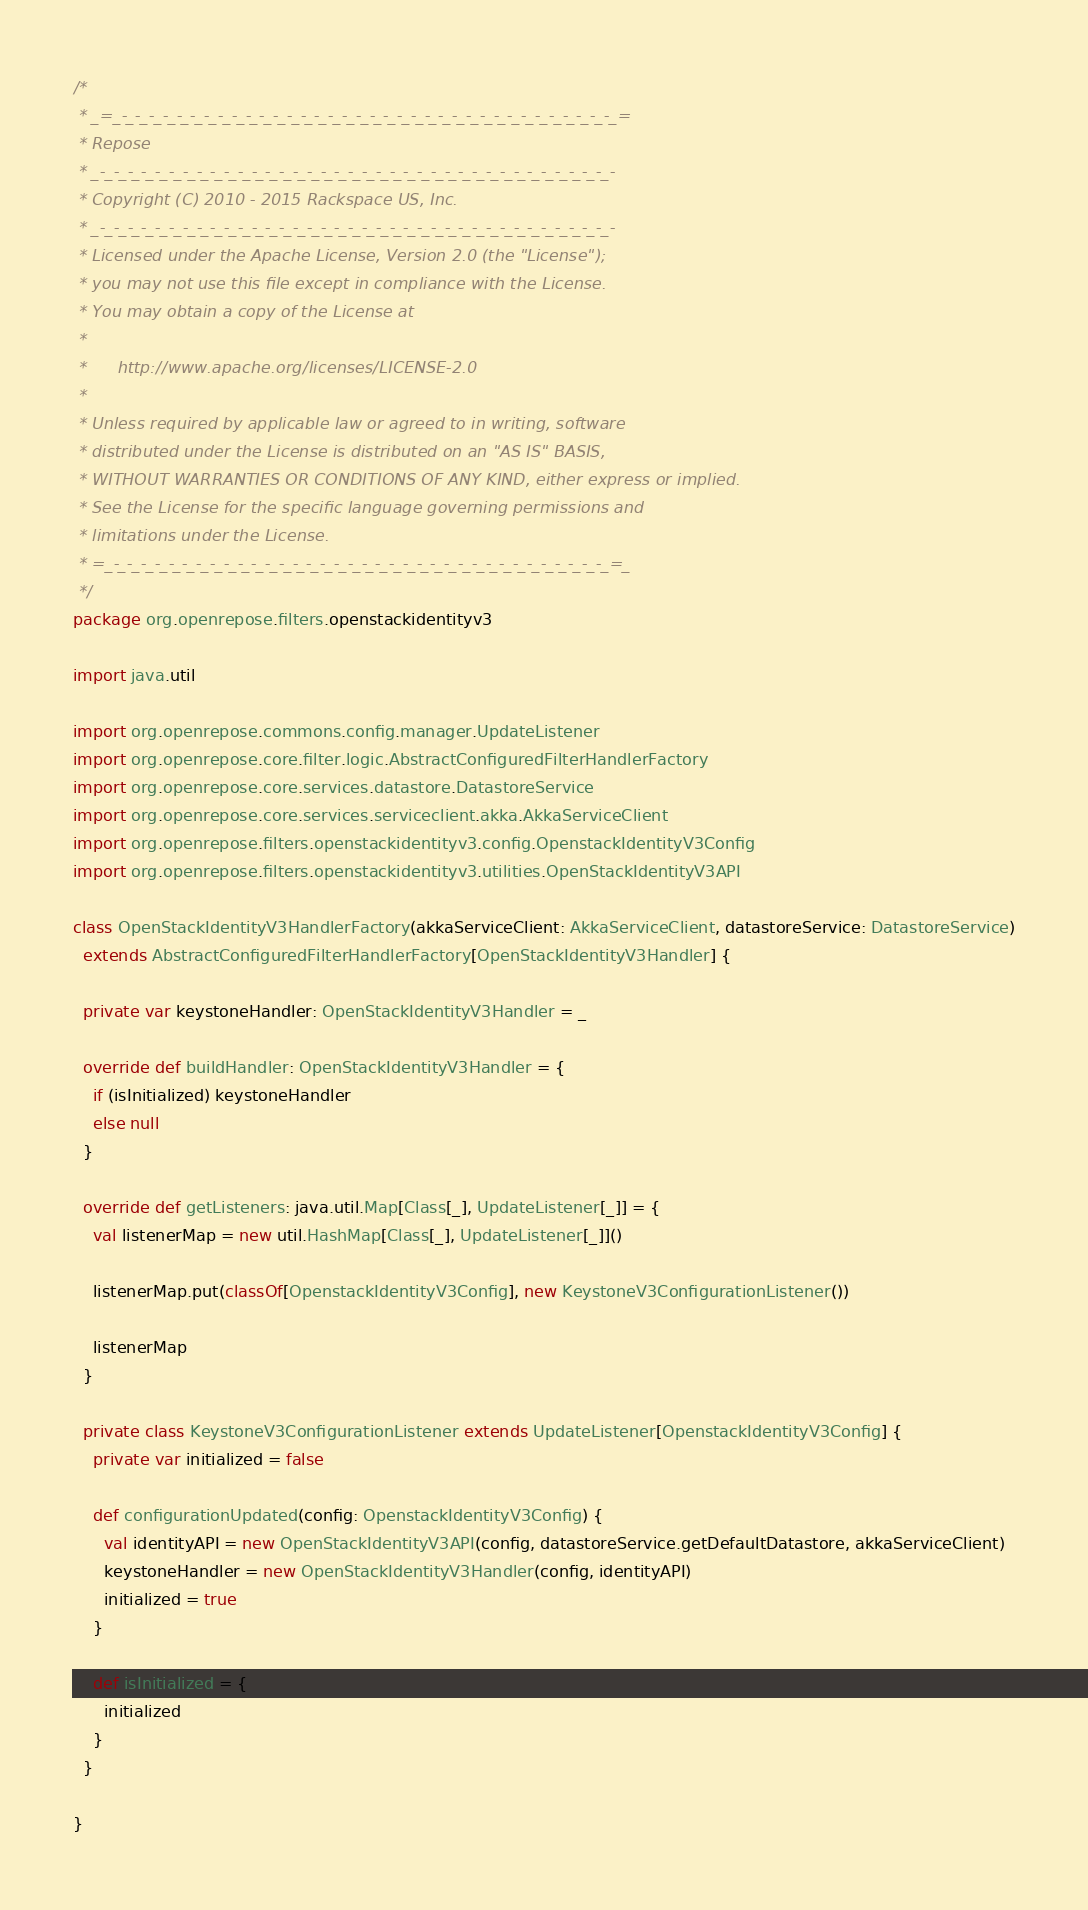Convert code to text. <code><loc_0><loc_0><loc_500><loc_500><_Scala_>/*
 * _=_-_-_-_-_-_-_-_-_-_-_-_-_-_-_-_-_-_-_-_-_-_-_-_-_-_-_-_-_-_-_-_-_-_-_-_-_=
 * Repose
 * _-_-_-_-_-_-_-_-_-_-_-_-_-_-_-_-_-_-_-_-_-_-_-_-_-_-_-_-_-_-_-_-_-_-_-_-_-_-
 * Copyright (C) 2010 - 2015 Rackspace US, Inc.
 * _-_-_-_-_-_-_-_-_-_-_-_-_-_-_-_-_-_-_-_-_-_-_-_-_-_-_-_-_-_-_-_-_-_-_-_-_-_-
 * Licensed under the Apache License, Version 2.0 (the "License");
 * you may not use this file except in compliance with the License.
 * You may obtain a copy of the License at
 * 
 *      http://www.apache.org/licenses/LICENSE-2.0
 * 
 * Unless required by applicable law or agreed to in writing, software
 * distributed under the License is distributed on an "AS IS" BASIS,
 * WITHOUT WARRANTIES OR CONDITIONS OF ANY KIND, either express or implied.
 * See the License for the specific language governing permissions and
 * limitations under the License.
 * =_-_-_-_-_-_-_-_-_-_-_-_-_-_-_-_-_-_-_-_-_-_-_-_-_-_-_-_-_-_-_-_-_-_-_-_-_=_
 */
package org.openrepose.filters.openstackidentityv3

import java.util

import org.openrepose.commons.config.manager.UpdateListener
import org.openrepose.core.filter.logic.AbstractConfiguredFilterHandlerFactory
import org.openrepose.core.services.datastore.DatastoreService
import org.openrepose.core.services.serviceclient.akka.AkkaServiceClient
import org.openrepose.filters.openstackidentityv3.config.OpenstackIdentityV3Config
import org.openrepose.filters.openstackidentityv3.utilities.OpenStackIdentityV3API

class OpenStackIdentityV3HandlerFactory(akkaServiceClient: AkkaServiceClient, datastoreService: DatastoreService)
  extends AbstractConfiguredFilterHandlerFactory[OpenStackIdentityV3Handler] {

  private var keystoneHandler: OpenStackIdentityV3Handler = _

  override def buildHandler: OpenStackIdentityV3Handler = {
    if (isInitialized) keystoneHandler
    else null
  }

  override def getListeners: java.util.Map[Class[_], UpdateListener[_]] = {
    val listenerMap = new util.HashMap[Class[_], UpdateListener[_]]()

    listenerMap.put(classOf[OpenstackIdentityV3Config], new KeystoneV3ConfigurationListener())

    listenerMap
  }

  private class KeystoneV3ConfigurationListener extends UpdateListener[OpenstackIdentityV3Config] {
    private var initialized = false

    def configurationUpdated(config: OpenstackIdentityV3Config) {
      val identityAPI = new OpenStackIdentityV3API(config, datastoreService.getDefaultDatastore, akkaServiceClient)
      keystoneHandler = new OpenStackIdentityV3Handler(config, identityAPI)
      initialized = true
    }

    def isInitialized = {
      initialized
    }
  }

}
</code> 